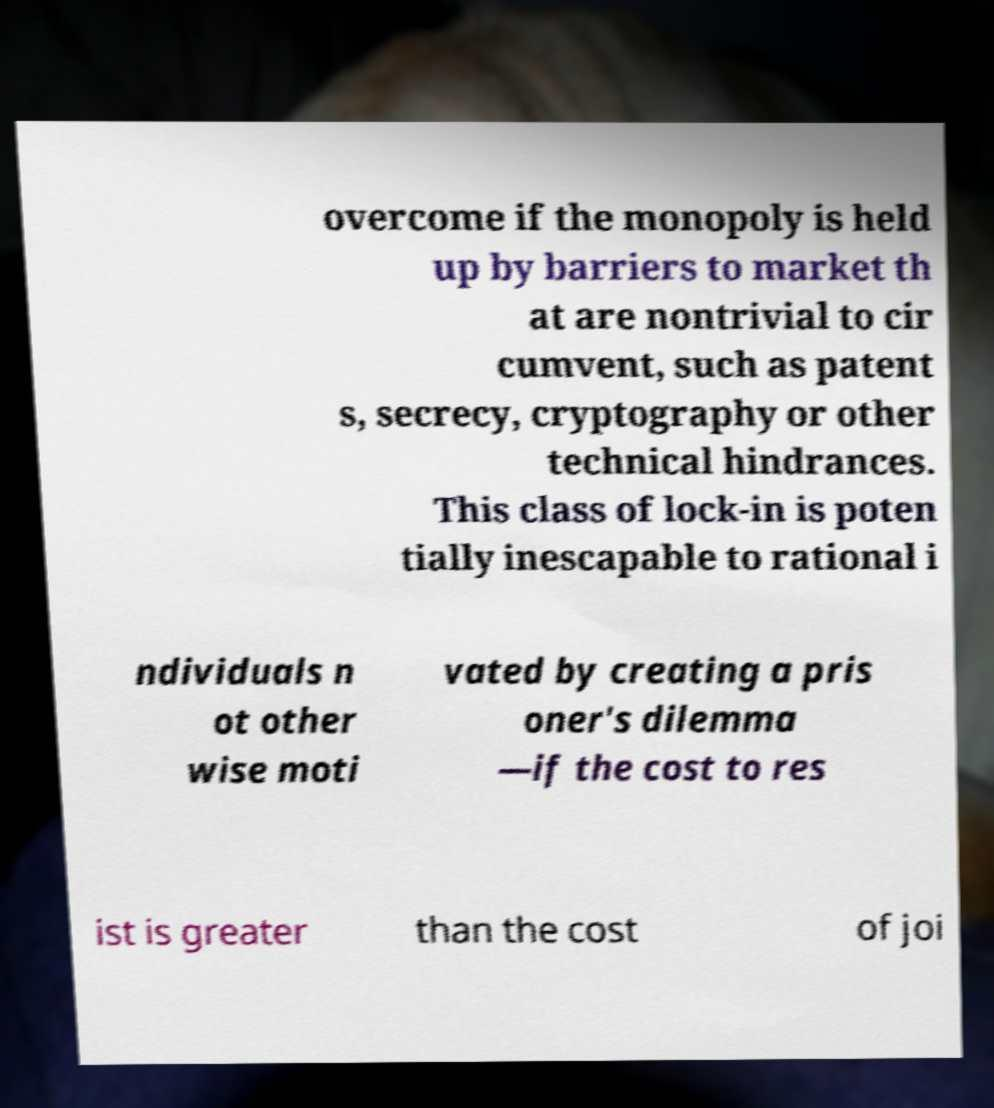Please identify and transcribe the text found in this image. overcome if the monopoly is held up by barriers to market th at are nontrivial to cir cumvent, such as patent s, secrecy, cryptography or other technical hindrances. This class of lock-in is poten tially inescapable to rational i ndividuals n ot other wise moti vated by creating a pris oner's dilemma —if the cost to res ist is greater than the cost of joi 